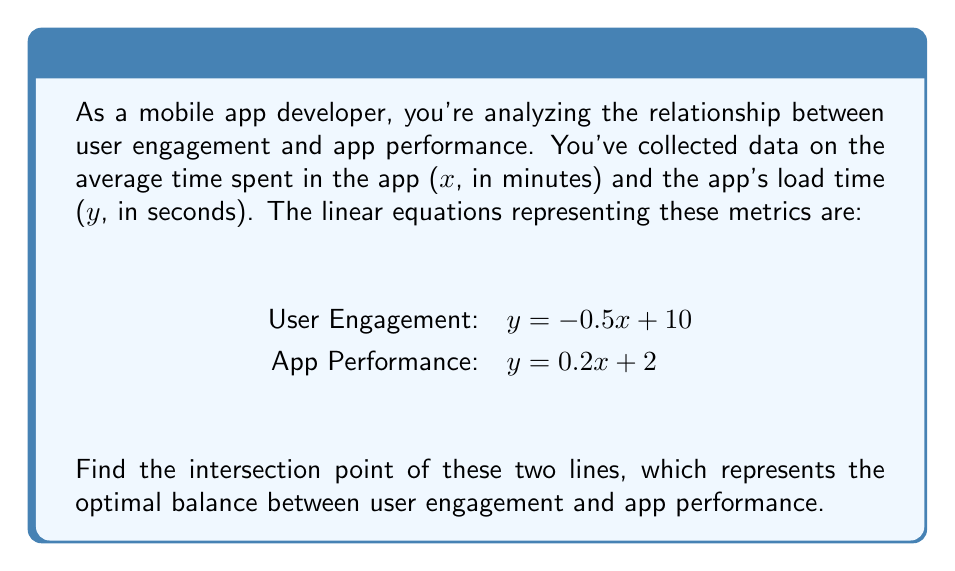Teach me how to tackle this problem. To find the intersection point of two linear equations, we need to solve them simultaneously. Let's approach this step-by-step:

1) We have two equations:
   $y = -0.5x + 10$ (User Engagement)
   $y = 0.2x + 2$ (App Performance)

2) At the intersection point, the y-values will be equal. So we can set the right sides of these equations equal to each other:

   $-0.5x + 10 = 0.2x + 2$

3) Now, let's solve this equation for x:

   $-0.5x + 10 = 0.2x + 2$
   $-0.5x - 0.2x = 2 - 10$
   $-0.7x = -8$
   $x = \frac{-8}{-0.7} = \frac{8}{0.7} \approx 11.43$

4) Now that we have the x-coordinate, we can find the y-coordinate by plugging this x-value into either of our original equations. Let's use the first one:

   $y = -0.5(11.43) + 10$
   $y = -5.715 + 10$
   $y = 4.285$

5) Therefore, the intersection point is approximately (11.43, 4.285).

This point represents the balance where user engagement (time spent in app) and app performance (load time) are optimized. At this point, users spend about 11.43 minutes in the app, and the app's load time is about 4.285 seconds.
Answer: The intersection point is approximately (11.43, 4.285). 